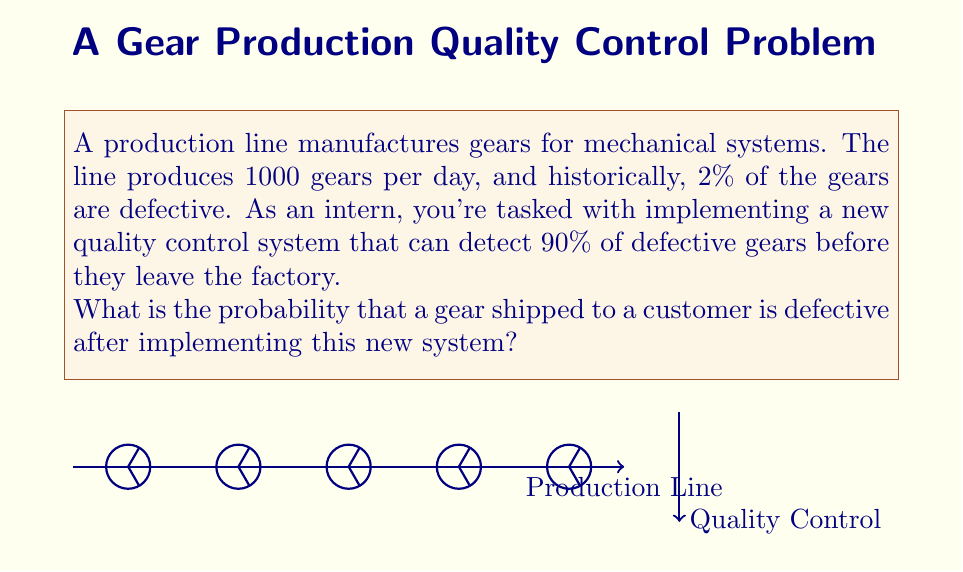Could you help me with this problem? Let's approach this step-by-step:

1) First, let's define our variables:
   $n$ = total number of gears produced per day = 1000
   $p$ = probability of a gear being defective = 0.02 (2%)
   $d$ = detection rate of the new quality control system = 0.90 (90%)

2) The number of defective gears produced per day is:
   $n \cdot p = 1000 \cdot 0.02 = 20$ defective gears

3) Of these defective gears, the number detected by the new system is:
   $20 \cdot d = 20 \cdot 0.90 = 18$ detected defective gears

4) This means the number of undetected defective gears is:
   $20 - 18 = 2$ undetected defective gears

5) The total number of gears shipped after quality control is:
   $1000 - 18 = 982$ gears

6) The probability of a shipped gear being defective is:
   $$P(\text{defective} | \text{shipped}) = \frac{\text{number of undetected defective gears}}{\text{total number of shipped gears}}$$
   
   $$P(\text{defective} | \text{shipped}) = \frac{2}{982} \approx 0.002037$$

Therefore, the probability of a shipped gear being defective after implementing the new quality control system is approximately 0.002037 or about 0.2037%.
Answer: $\frac{2}{982} \approx 0.002037$ (0.2037%) 